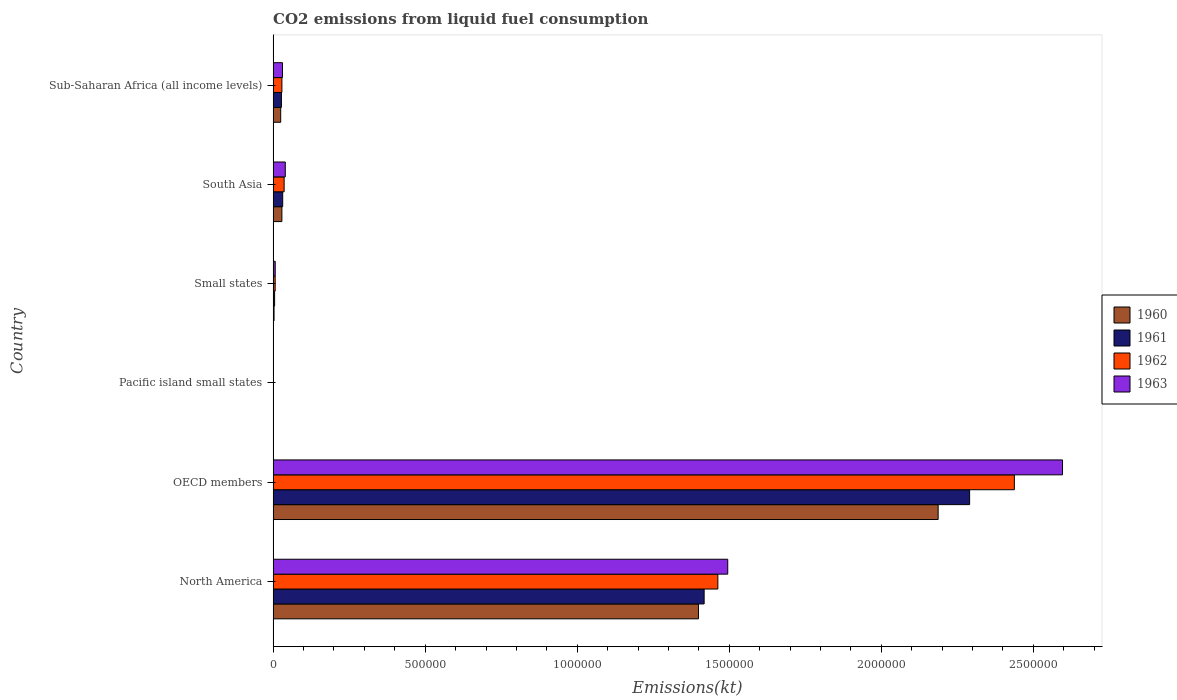How many groups of bars are there?
Offer a terse response. 6. Are the number of bars per tick equal to the number of legend labels?
Keep it short and to the point. Yes. How many bars are there on the 3rd tick from the top?
Provide a succinct answer. 4. How many bars are there on the 1st tick from the bottom?
Give a very brief answer. 4. What is the label of the 4th group of bars from the top?
Your answer should be compact. Pacific island small states. What is the amount of CO2 emitted in 1960 in OECD members?
Offer a terse response. 2.19e+06. Across all countries, what is the maximum amount of CO2 emitted in 1963?
Your response must be concise. 2.60e+06. Across all countries, what is the minimum amount of CO2 emitted in 1962?
Provide a succinct answer. 383.86. In which country was the amount of CO2 emitted in 1961 minimum?
Your answer should be compact. Pacific island small states. What is the total amount of CO2 emitted in 1963 in the graph?
Keep it short and to the point. 4.17e+06. What is the difference between the amount of CO2 emitted in 1960 in OECD members and that in Small states?
Give a very brief answer. 2.18e+06. What is the difference between the amount of CO2 emitted in 1963 in Sub-Saharan Africa (all income levels) and the amount of CO2 emitted in 1962 in Small states?
Keep it short and to the point. 2.41e+04. What is the average amount of CO2 emitted in 1961 per country?
Provide a short and direct response. 6.29e+05. What is the difference between the amount of CO2 emitted in 1962 and amount of CO2 emitted in 1963 in Small states?
Ensure brevity in your answer.  -173.55. What is the ratio of the amount of CO2 emitted in 1960 in North America to that in South Asia?
Offer a terse response. 48.52. Is the amount of CO2 emitted in 1963 in Pacific island small states less than that in Sub-Saharan Africa (all income levels)?
Your answer should be compact. Yes. Is the difference between the amount of CO2 emitted in 1962 in OECD members and Sub-Saharan Africa (all income levels) greater than the difference between the amount of CO2 emitted in 1963 in OECD members and Sub-Saharan Africa (all income levels)?
Offer a very short reply. No. What is the difference between the highest and the second highest amount of CO2 emitted in 1961?
Your answer should be very brief. 8.73e+05. What is the difference between the highest and the lowest amount of CO2 emitted in 1962?
Offer a very short reply. 2.44e+06. What does the 1st bar from the top in Pacific island small states represents?
Provide a short and direct response. 1963. What does the 4th bar from the bottom in Small states represents?
Offer a very short reply. 1963. What is the difference between two consecutive major ticks on the X-axis?
Ensure brevity in your answer.  5.00e+05. Are the values on the major ticks of X-axis written in scientific E-notation?
Keep it short and to the point. No. Does the graph contain any zero values?
Keep it short and to the point. No. Does the graph contain grids?
Offer a very short reply. No. Where does the legend appear in the graph?
Provide a short and direct response. Center right. How many legend labels are there?
Make the answer very short. 4. How are the legend labels stacked?
Keep it short and to the point. Vertical. What is the title of the graph?
Offer a terse response. CO2 emissions from liquid fuel consumption. Does "1977" appear as one of the legend labels in the graph?
Your response must be concise. No. What is the label or title of the X-axis?
Ensure brevity in your answer.  Emissions(kt). What is the label or title of the Y-axis?
Offer a very short reply. Country. What is the Emissions(kt) of 1960 in North America?
Your response must be concise. 1.40e+06. What is the Emissions(kt) in 1961 in North America?
Offer a terse response. 1.42e+06. What is the Emissions(kt) of 1962 in North America?
Your response must be concise. 1.46e+06. What is the Emissions(kt) in 1963 in North America?
Your answer should be compact. 1.49e+06. What is the Emissions(kt) in 1960 in OECD members?
Offer a very short reply. 2.19e+06. What is the Emissions(kt) in 1961 in OECD members?
Give a very brief answer. 2.29e+06. What is the Emissions(kt) in 1962 in OECD members?
Provide a succinct answer. 2.44e+06. What is the Emissions(kt) in 1963 in OECD members?
Your response must be concise. 2.60e+06. What is the Emissions(kt) of 1960 in Pacific island small states?
Your answer should be very brief. 281.37. What is the Emissions(kt) in 1961 in Pacific island small states?
Ensure brevity in your answer.  317.67. What is the Emissions(kt) in 1962 in Pacific island small states?
Ensure brevity in your answer.  383.86. What is the Emissions(kt) of 1963 in Pacific island small states?
Provide a short and direct response. 412.14. What is the Emissions(kt) of 1960 in Small states?
Provide a short and direct response. 3043.74. What is the Emissions(kt) in 1961 in Small states?
Provide a succinct answer. 4870.9. What is the Emissions(kt) in 1962 in Small states?
Provide a short and direct response. 6726.15. What is the Emissions(kt) of 1963 in Small states?
Give a very brief answer. 6899.7. What is the Emissions(kt) of 1960 in South Asia?
Give a very brief answer. 2.88e+04. What is the Emissions(kt) in 1961 in South Asia?
Keep it short and to the point. 3.15e+04. What is the Emissions(kt) of 1962 in South Asia?
Your answer should be very brief. 3.62e+04. What is the Emissions(kt) in 1963 in South Asia?
Ensure brevity in your answer.  4.00e+04. What is the Emissions(kt) of 1960 in Sub-Saharan Africa (all income levels)?
Keep it short and to the point. 2.49e+04. What is the Emissions(kt) in 1961 in Sub-Saharan Africa (all income levels)?
Your response must be concise. 2.73e+04. What is the Emissions(kt) of 1962 in Sub-Saharan Africa (all income levels)?
Your answer should be very brief. 2.89e+04. What is the Emissions(kt) in 1963 in Sub-Saharan Africa (all income levels)?
Your answer should be very brief. 3.08e+04. Across all countries, what is the maximum Emissions(kt) of 1960?
Offer a terse response. 2.19e+06. Across all countries, what is the maximum Emissions(kt) in 1961?
Your response must be concise. 2.29e+06. Across all countries, what is the maximum Emissions(kt) of 1962?
Provide a succinct answer. 2.44e+06. Across all countries, what is the maximum Emissions(kt) of 1963?
Ensure brevity in your answer.  2.60e+06. Across all countries, what is the minimum Emissions(kt) in 1960?
Keep it short and to the point. 281.37. Across all countries, what is the minimum Emissions(kt) of 1961?
Your response must be concise. 317.67. Across all countries, what is the minimum Emissions(kt) of 1962?
Provide a succinct answer. 383.86. Across all countries, what is the minimum Emissions(kt) of 1963?
Offer a very short reply. 412.14. What is the total Emissions(kt) of 1960 in the graph?
Your answer should be very brief. 3.64e+06. What is the total Emissions(kt) in 1961 in the graph?
Provide a short and direct response. 3.77e+06. What is the total Emissions(kt) of 1962 in the graph?
Make the answer very short. 3.97e+06. What is the total Emissions(kt) of 1963 in the graph?
Your response must be concise. 4.17e+06. What is the difference between the Emissions(kt) in 1960 in North America and that in OECD members?
Keep it short and to the point. -7.88e+05. What is the difference between the Emissions(kt) in 1961 in North America and that in OECD members?
Provide a short and direct response. -8.73e+05. What is the difference between the Emissions(kt) in 1962 in North America and that in OECD members?
Offer a very short reply. -9.75e+05. What is the difference between the Emissions(kt) of 1963 in North America and that in OECD members?
Offer a very short reply. -1.10e+06. What is the difference between the Emissions(kt) of 1960 in North America and that in Pacific island small states?
Make the answer very short. 1.40e+06. What is the difference between the Emissions(kt) of 1961 in North America and that in Pacific island small states?
Keep it short and to the point. 1.42e+06. What is the difference between the Emissions(kt) in 1962 in North America and that in Pacific island small states?
Provide a succinct answer. 1.46e+06. What is the difference between the Emissions(kt) of 1963 in North America and that in Pacific island small states?
Your answer should be compact. 1.49e+06. What is the difference between the Emissions(kt) of 1960 in North America and that in Small states?
Keep it short and to the point. 1.40e+06. What is the difference between the Emissions(kt) in 1961 in North America and that in Small states?
Give a very brief answer. 1.41e+06. What is the difference between the Emissions(kt) in 1962 in North America and that in Small states?
Your answer should be very brief. 1.46e+06. What is the difference between the Emissions(kt) in 1963 in North America and that in Small states?
Keep it short and to the point. 1.49e+06. What is the difference between the Emissions(kt) in 1960 in North America and that in South Asia?
Give a very brief answer. 1.37e+06. What is the difference between the Emissions(kt) in 1961 in North America and that in South Asia?
Your answer should be very brief. 1.39e+06. What is the difference between the Emissions(kt) in 1962 in North America and that in South Asia?
Keep it short and to the point. 1.43e+06. What is the difference between the Emissions(kt) of 1963 in North America and that in South Asia?
Give a very brief answer. 1.45e+06. What is the difference between the Emissions(kt) in 1960 in North America and that in Sub-Saharan Africa (all income levels)?
Your answer should be very brief. 1.37e+06. What is the difference between the Emissions(kt) of 1961 in North America and that in Sub-Saharan Africa (all income levels)?
Provide a succinct answer. 1.39e+06. What is the difference between the Emissions(kt) in 1962 in North America and that in Sub-Saharan Africa (all income levels)?
Provide a succinct answer. 1.43e+06. What is the difference between the Emissions(kt) in 1963 in North America and that in Sub-Saharan Africa (all income levels)?
Offer a terse response. 1.46e+06. What is the difference between the Emissions(kt) of 1960 in OECD members and that in Pacific island small states?
Offer a very short reply. 2.19e+06. What is the difference between the Emissions(kt) of 1961 in OECD members and that in Pacific island small states?
Ensure brevity in your answer.  2.29e+06. What is the difference between the Emissions(kt) of 1962 in OECD members and that in Pacific island small states?
Give a very brief answer. 2.44e+06. What is the difference between the Emissions(kt) of 1963 in OECD members and that in Pacific island small states?
Offer a terse response. 2.60e+06. What is the difference between the Emissions(kt) of 1960 in OECD members and that in Small states?
Make the answer very short. 2.18e+06. What is the difference between the Emissions(kt) of 1961 in OECD members and that in Small states?
Offer a very short reply. 2.29e+06. What is the difference between the Emissions(kt) of 1962 in OECD members and that in Small states?
Provide a short and direct response. 2.43e+06. What is the difference between the Emissions(kt) in 1963 in OECD members and that in Small states?
Give a very brief answer. 2.59e+06. What is the difference between the Emissions(kt) of 1960 in OECD members and that in South Asia?
Your answer should be very brief. 2.16e+06. What is the difference between the Emissions(kt) in 1961 in OECD members and that in South Asia?
Keep it short and to the point. 2.26e+06. What is the difference between the Emissions(kt) in 1962 in OECD members and that in South Asia?
Give a very brief answer. 2.40e+06. What is the difference between the Emissions(kt) of 1963 in OECD members and that in South Asia?
Your answer should be very brief. 2.56e+06. What is the difference between the Emissions(kt) of 1960 in OECD members and that in Sub-Saharan Africa (all income levels)?
Provide a succinct answer. 2.16e+06. What is the difference between the Emissions(kt) in 1961 in OECD members and that in Sub-Saharan Africa (all income levels)?
Provide a short and direct response. 2.26e+06. What is the difference between the Emissions(kt) of 1962 in OECD members and that in Sub-Saharan Africa (all income levels)?
Your answer should be compact. 2.41e+06. What is the difference between the Emissions(kt) of 1963 in OECD members and that in Sub-Saharan Africa (all income levels)?
Offer a very short reply. 2.56e+06. What is the difference between the Emissions(kt) of 1960 in Pacific island small states and that in Small states?
Provide a succinct answer. -2762.37. What is the difference between the Emissions(kt) in 1961 in Pacific island small states and that in Small states?
Your response must be concise. -4553.22. What is the difference between the Emissions(kt) of 1962 in Pacific island small states and that in Small states?
Make the answer very short. -6342.29. What is the difference between the Emissions(kt) in 1963 in Pacific island small states and that in Small states?
Offer a very short reply. -6487.56. What is the difference between the Emissions(kt) of 1960 in Pacific island small states and that in South Asia?
Your answer should be very brief. -2.85e+04. What is the difference between the Emissions(kt) of 1961 in Pacific island small states and that in South Asia?
Give a very brief answer. -3.12e+04. What is the difference between the Emissions(kt) in 1962 in Pacific island small states and that in South Asia?
Provide a short and direct response. -3.58e+04. What is the difference between the Emissions(kt) in 1963 in Pacific island small states and that in South Asia?
Provide a short and direct response. -3.96e+04. What is the difference between the Emissions(kt) in 1960 in Pacific island small states and that in Sub-Saharan Africa (all income levels)?
Offer a terse response. -2.46e+04. What is the difference between the Emissions(kt) of 1961 in Pacific island small states and that in Sub-Saharan Africa (all income levels)?
Ensure brevity in your answer.  -2.70e+04. What is the difference between the Emissions(kt) in 1962 in Pacific island small states and that in Sub-Saharan Africa (all income levels)?
Offer a terse response. -2.85e+04. What is the difference between the Emissions(kt) of 1963 in Pacific island small states and that in Sub-Saharan Africa (all income levels)?
Offer a very short reply. -3.04e+04. What is the difference between the Emissions(kt) in 1960 in Small states and that in South Asia?
Keep it short and to the point. -2.58e+04. What is the difference between the Emissions(kt) in 1961 in Small states and that in South Asia?
Your answer should be compact. -2.66e+04. What is the difference between the Emissions(kt) in 1962 in Small states and that in South Asia?
Your answer should be very brief. -2.95e+04. What is the difference between the Emissions(kt) in 1963 in Small states and that in South Asia?
Keep it short and to the point. -3.31e+04. What is the difference between the Emissions(kt) in 1960 in Small states and that in Sub-Saharan Africa (all income levels)?
Your response must be concise. -2.19e+04. What is the difference between the Emissions(kt) in 1961 in Small states and that in Sub-Saharan Africa (all income levels)?
Provide a succinct answer. -2.25e+04. What is the difference between the Emissions(kt) in 1962 in Small states and that in Sub-Saharan Africa (all income levels)?
Make the answer very short. -2.22e+04. What is the difference between the Emissions(kt) of 1963 in Small states and that in Sub-Saharan Africa (all income levels)?
Your answer should be compact. -2.39e+04. What is the difference between the Emissions(kt) of 1960 in South Asia and that in Sub-Saharan Africa (all income levels)?
Provide a succinct answer. 3916.59. What is the difference between the Emissions(kt) in 1961 in South Asia and that in Sub-Saharan Africa (all income levels)?
Provide a short and direct response. 4173.93. What is the difference between the Emissions(kt) of 1962 in South Asia and that in Sub-Saharan Africa (all income levels)?
Provide a succinct answer. 7305.47. What is the difference between the Emissions(kt) in 1963 in South Asia and that in Sub-Saharan Africa (all income levels)?
Make the answer very short. 9178.66. What is the difference between the Emissions(kt) in 1960 in North America and the Emissions(kt) in 1961 in OECD members?
Your answer should be compact. -8.92e+05. What is the difference between the Emissions(kt) in 1960 in North America and the Emissions(kt) in 1962 in OECD members?
Your response must be concise. -1.04e+06. What is the difference between the Emissions(kt) in 1960 in North America and the Emissions(kt) in 1963 in OECD members?
Your response must be concise. -1.20e+06. What is the difference between the Emissions(kt) in 1961 in North America and the Emissions(kt) in 1962 in OECD members?
Your answer should be compact. -1.02e+06. What is the difference between the Emissions(kt) of 1961 in North America and the Emissions(kt) of 1963 in OECD members?
Offer a terse response. -1.18e+06. What is the difference between the Emissions(kt) in 1962 in North America and the Emissions(kt) in 1963 in OECD members?
Ensure brevity in your answer.  -1.13e+06. What is the difference between the Emissions(kt) in 1960 in North America and the Emissions(kt) in 1961 in Pacific island small states?
Make the answer very short. 1.40e+06. What is the difference between the Emissions(kt) in 1960 in North America and the Emissions(kt) in 1962 in Pacific island small states?
Offer a terse response. 1.40e+06. What is the difference between the Emissions(kt) in 1960 in North America and the Emissions(kt) in 1963 in Pacific island small states?
Make the answer very short. 1.40e+06. What is the difference between the Emissions(kt) of 1961 in North America and the Emissions(kt) of 1962 in Pacific island small states?
Your answer should be compact. 1.42e+06. What is the difference between the Emissions(kt) of 1961 in North America and the Emissions(kt) of 1963 in Pacific island small states?
Give a very brief answer. 1.42e+06. What is the difference between the Emissions(kt) in 1962 in North America and the Emissions(kt) in 1963 in Pacific island small states?
Give a very brief answer. 1.46e+06. What is the difference between the Emissions(kt) in 1960 in North America and the Emissions(kt) in 1961 in Small states?
Make the answer very short. 1.39e+06. What is the difference between the Emissions(kt) in 1960 in North America and the Emissions(kt) in 1962 in Small states?
Your answer should be compact. 1.39e+06. What is the difference between the Emissions(kt) in 1960 in North America and the Emissions(kt) in 1963 in Small states?
Ensure brevity in your answer.  1.39e+06. What is the difference between the Emissions(kt) in 1961 in North America and the Emissions(kt) in 1962 in Small states?
Make the answer very short. 1.41e+06. What is the difference between the Emissions(kt) of 1961 in North America and the Emissions(kt) of 1963 in Small states?
Your response must be concise. 1.41e+06. What is the difference between the Emissions(kt) of 1962 in North America and the Emissions(kt) of 1963 in Small states?
Your response must be concise. 1.46e+06. What is the difference between the Emissions(kt) in 1960 in North America and the Emissions(kt) in 1961 in South Asia?
Provide a succinct answer. 1.37e+06. What is the difference between the Emissions(kt) of 1960 in North America and the Emissions(kt) of 1962 in South Asia?
Your answer should be very brief. 1.36e+06. What is the difference between the Emissions(kt) of 1960 in North America and the Emissions(kt) of 1963 in South Asia?
Keep it short and to the point. 1.36e+06. What is the difference between the Emissions(kt) in 1961 in North America and the Emissions(kt) in 1962 in South Asia?
Make the answer very short. 1.38e+06. What is the difference between the Emissions(kt) of 1961 in North America and the Emissions(kt) of 1963 in South Asia?
Offer a very short reply. 1.38e+06. What is the difference between the Emissions(kt) of 1962 in North America and the Emissions(kt) of 1963 in South Asia?
Keep it short and to the point. 1.42e+06. What is the difference between the Emissions(kt) of 1960 in North America and the Emissions(kt) of 1961 in Sub-Saharan Africa (all income levels)?
Make the answer very short. 1.37e+06. What is the difference between the Emissions(kt) of 1960 in North America and the Emissions(kt) of 1962 in Sub-Saharan Africa (all income levels)?
Provide a succinct answer. 1.37e+06. What is the difference between the Emissions(kt) of 1960 in North America and the Emissions(kt) of 1963 in Sub-Saharan Africa (all income levels)?
Keep it short and to the point. 1.37e+06. What is the difference between the Emissions(kt) of 1961 in North America and the Emissions(kt) of 1962 in Sub-Saharan Africa (all income levels)?
Your answer should be very brief. 1.39e+06. What is the difference between the Emissions(kt) of 1961 in North America and the Emissions(kt) of 1963 in Sub-Saharan Africa (all income levels)?
Provide a succinct answer. 1.39e+06. What is the difference between the Emissions(kt) of 1962 in North America and the Emissions(kt) of 1963 in Sub-Saharan Africa (all income levels)?
Your answer should be compact. 1.43e+06. What is the difference between the Emissions(kt) of 1960 in OECD members and the Emissions(kt) of 1961 in Pacific island small states?
Ensure brevity in your answer.  2.19e+06. What is the difference between the Emissions(kt) of 1960 in OECD members and the Emissions(kt) of 1962 in Pacific island small states?
Provide a succinct answer. 2.19e+06. What is the difference between the Emissions(kt) of 1960 in OECD members and the Emissions(kt) of 1963 in Pacific island small states?
Your answer should be very brief. 2.19e+06. What is the difference between the Emissions(kt) of 1961 in OECD members and the Emissions(kt) of 1962 in Pacific island small states?
Your answer should be compact. 2.29e+06. What is the difference between the Emissions(kt) in 1961 in OECD members and the Emissions(kt) in 1963 in Pacific island small states?
Your answer should be compact. 2.29e+06. What is the difference between the Emissions(kt) in 1962 in OECD members and the Emissions(kt) in 1963 in Pacific island small states?
Your answer should be compact. 2.44e+06. What is the difference between the Emissions(kt) in 1960 in OECD members and the Emissions(kt) in 1961 in Small states?
Ensure brevity in your answer.  2.18e+06. What is the difference between the Emissions(kt) of 1960 in OECD members and the Emissions(kt) of 1962 in Small states?
Offer a very short reply. 2.18e+06. What is the difference between the Emissions(kt) of 1960 in OECD members and the Emissions(kt) of 1963 in Small states?
Your answer should be very brief. 2.18e+06. What is the difference between the Emissions(kt) of 1961 in OECD members and the Emissions(kt) of 1962 in Small states?
Your answer should be compact. 2.28e+06. What is the difference between the Emissions(kt) of 1961 in OECD members and the Emissions(kt) of 1963 in Small states?
Ensure brevity in your answer.  2.28e+06. What is the difference between the Emissions(kt) of 1962 in OECD members and the Emissions(kt) of 1963 in Small states?
Your answer should be very brief. 2.43e+06. What is the difference between the Emissions(kt) in 1960 in OECD members and the Emissions(kt) in 1961 in South Asia?
Provide a short and direct response. 2.16e+06. What is the difference between the Emissions(kt) in 1960 in OECD members and the Emissions(kt) in 1962 in South Asia?
Your answer should be very brief. 2.15e+06. What is the difference between the Emissions(kt) in 1960 in OECD members and the Emissions(kt) in 1963 in South Asia?
Your response must be concise. 2.15e+06. What is the difference between the Emissions(kt) of 1961 in OECD members and the Emissions(kt) of 1962 in South Asia?
Give a very brief answer. 2.25e+06. What is the difference between the Emissions(kt) in 1961 in OECD members and the Emissions(kt) in 1963 in South Asia?
Your answer should be very brief. 2.25e+06. What is the difference between the Emissions(kt) in 1962 in OECD members and the Emissions(kt) in 1963 in South Asia?
Make the answer very short. 2.40e+06. What is the difference between the Emissions(kt) in 1960 in OECD members and the Emissions(kt) in 1961 in Sub-Saharan Africa (all income levels)?
Your answer should be very brief. 2.16e+06. What is the difference between the Emissions(kt) in 1960 in OECD members and the Emissions(kt) in 1962 in Sub-Saharan Africa (all income levels)?
Offer a terse response. 2.16e+06. What is the difference between the Emissions(kt) of 1960 in OECD members and the Emissions(kt) of 1963 in Sub-Saharan Africa (all income levels)?
Provide a short and direct response. 2.16e+06. What is the difference between the Emissions(kt) in 1961 in OECD members and the Emissions(kt) in 1962 in Sub-Saharan Africa (all income levels)?
Your response must be concise. 2.26e+06. What is the difference between the Emissions(kt) in 1961 in OECD members and the Emissions(kt) in 1963 in Sub-Saharan Africa (all income levels)?
Your answer should be very brief. 2.26e+06. What is the difference between the Emissions(kt) in 1962 in OECD members and the Emissions(kt) in 1963 in Sub-Saharan Africa (all income levels)?
Your answer should be compact. 2.41e+06. What is the difference between the Emissions(kt) of 1960 in Pacific island small states and the Emissions(kt) of 1961 in Small states?
Provide a succinct answer. -4589.53. What is the difference between the Emissions(kt) of 1960 in Pacific island small states and the Emissions(kt) of 1962 in Small states?
Make the answer very short. -6444.78. What is the difference between the Emissions(kt) in 1960 in Pacific island small states and the Emissions(kt) in 1963 in Small states?
Your response must be concise. -6618.33. What is the difference between the Emissions(kt) of 1961 in Pacific island small states and the Emissions(kt) of 1962 in Small states?
Ensure brevity in your answer.  -6408.48. What is the difference between the Emissions(kt) of 1961 in Pacific island small states and the Emissions(kt) of 1963 in Small states?
Your answer should be very brief. -6582.02. What is the difference between the Emissions(kt) of 1962 in Pacific island small states and the Emissions(kt) of 1963 in Small states?
Provide a succinct answer. -6515.84. What is the difference between the Emissions(kt) in 1960 in Pacific island small states and the Emissions(kt) in 1961 in South Asia?
Provide a short and direct response. -3.12e+04. What is the difference between the Emissions(kt) in 1960 in Pacific island small states and the Emissions(kt) in 1962 in South Asia?
Offer a terse response. -3.59e+04. What is the difference between the Emissions(kt) in 1960 in Pacific island small states and the Emissions(kt) in 1963 in South Asia?
Your response must be concise. -3.97e+04. What is the difference between the Emissions(kt) of 1961 in Pacific island small states and the Emissions(kt) of 1962 in South Asia?
Provide a succinct answer. -3.59e+04. What is the difference between the Emissions(kt) of 1961 in Pacific island small states and the Emissions(kt) of 1963 in South Asia?
Keep it short and to the point. -3.97e+04. What is the difference between the Emissions(kt) in 1962 in Pacific island small states and the Emissions(kt) in 1963 in South Asia?
Provide a short and direct response. -3.96e+04. What is the difference between the Emissions(kt) in 1960 in Pacific island small states and the Emissions(kt) in 1961 in Sub-Saharan Africa (all income levels)?
Make the answer very short. -2.71e+04. What is the difference between the Emissions(kt) of 1960 in Pacific island small states and the Emissions(kt) of 1962 in Sub-Saharan Africa (all income levels)?
Your response must be concise. -2.86e+04. What is the difference between the Emissions(kt) of 1960 in Pacific island small states and the Emissions(kt) of 1963 in Sub-Saharan Africa (all income levels)?
Make the answer very short. -3.05e+04. What is the difference between the Emissions(kt) in 1961 in Pacific island small states and the Emissions(kt) in 1962 in Sub-Saharan Africa (all income levels)?
Offer a terse response. -2.86e+04. What is the difference between the Emissions(kt) in 1961 in Pacific island small states and the Emissions(kt) in 1963 in Sub-Saharan Africa (all income levels)?
Make the answer very short. -3.05e+04. What is the difference between the Emissions(kt) in 1962 in Pacific island small states and the Emissions(kt) in 1963 in Sub-Saharan Africa (all income levels)?
Offer a very short reply. -3.04e+04. What is the difference between the Emissions(kt) of 1960 in Small states and the Emissions(kt) of 1961 in South Asia?
Your answer should be compact. -2.85e+04. What is the difference between the Emissions(kt) of 1960 in Small states and the Emissions(kt) of 1962 in South Asia?
Make the answer very short. -3.32e+04. What is the difference between the Emissions(kt) in 1960 in Small states and the Emissions(kt) in 1963 in South Asia?
Keep it short and to the point. -3.69e+04. What is the difference between the Emissions(kt) of 1961 in Small states and the Emissions(kt) of 1962 in South Asia?
Provide a short and direct response. -3.13e+04. What is the difference between the Emissions(kt) of 1961 in Small states and the Emissions(kt) of 1963 in South Asia?
Give a very brief answer. -3.51e+04. What is the difference between the Emissions(kt) of 1962 in Small states and the Emissions(kt) of 1963 in South Asia?
Keep it short and to the point. -3.33e+04. What is the difference between the Emissions(kt) of 1960 in Small states and the Emissions(kt) of 1961 in Sub-Saharan Africa (all income levels)?
Your response must be concise. -2.43e+04. What is the difference between the Emissions(kt) of 1960 in Small states and the Emissions(kt) of 1962 in Sub-Saharan Africa (all income levels)?
Provide a succinct answer. -2.58e+04. What is the difference between the Emissions(kt) of 1960 in Small states and the Emissions(kt) of 1963 in Sub-Saharan Africa (all income levels)?
Provide a succinct answer. -2.78e+04. What is the difference between the Emissions(kt) of 1961 in Small states and the Emissions(kt) of 1962 in Sub-Saharan Africa (all income levels)?
Make the answer very short. -2.40e+04. What is the difference between the Emissions(kt) in 1961 in Small states and the Emissions(kt) in 1963 in Sub-Saharan Africa (all income levels)?
Provide a succinct answer. -2.59e+04. What is the difference between the Emissions(kt) of 1962 in Small states and the Emissions(kt) of 1963 in Sub-Saharan Africa (all income levels)?
Provide a succinct answer. -2.41e+04. What is the difference between the Emissions(kt) in 1960 in South Asia and the Emissions(kt) in 1961 in Sub-Saharan Africa (all income levels)?
Offer a terse response. 1497.94. What is the difference between the Emissions(kt) of 1960 in South Asia and the Emissions(kt) of 1962 in Sub-Saharan Africa (all income levels)?
Offer a very short reply. -62.97. What is the difference between the Emissions(kt) in 1960 in South Asia and the Emissions(kt) in 1963 in Sub-Saharan Africa (all income levels)?
Your answer should be compact. -1980.13. What is the difference between the Emissions(kt) in 1961 in South Asia and the Emissions(kt) in 1962 in Sub-Saharan Africa (all income levels)?
Provide a short and direct response. 2613.02. What is the difference between the Emissions(kt) of 1961 in South Asia and the Emissions(kt) of 1963 in Sub-Saharan Africa (all income levels)?
Your answer should be compact. 695.86. What is the difference between the Emissions(kt) of 1962 in South Asia and the Emissions(kt) of 1963 in Sub-Saharan Africa (all income levels)?
Offer a very short reply. 5388.31. What is the average Emissions(kt) of 1960 per country?
Ensure brevity in your answer.  6.07e+05. What is the average Emissions(kt) of 1961 per country?
Offer a very short reply. 6.29e+05. What is the average Emissions(kt) in 1962 per country?
Keep it short and to the point. 6.62e+05. What is the average Emissions(kt) in 1963 per country?
Make the answer very short. 6.95e+05. What is the difference between the Emissions(kt) of 1960 and Emissions(kt) of 1961 in North America?
Keep it short and to the point. -1.86e+04. What is the difference between the Emissions(kt) of 1960 and Emissions(kt) of 1962 in North America?
Keep it short and to the point. -6.37e+04. What is the difference between the Emissions(kt) of 1960 and Emissions(kt) of 1963 in North America?
Keep it short and to the point. -9.62e+04. What is the difference between the Emissions(kt) of 1961 and Emissions(kt) of 1962 in North America?
Give a very brief answer. -4.51e+04. What is the difference between the Emissions(kt) in 1961 and Emissions(kt) in 1963 in North America?
Provide a short and direct response. -7.76e+04. What is the difference between the Emissions(kt) of 1962 and Emissions(kt) of 1963 in North America?
Your answer should be very brief. -3.25e+04. What is the difference between the Emissions(kt) in 1960 and Emissions(kt) in 1961 in OECD members?
Your answer should be compact. -1.04e+05. What is the difference between the Emissions(kt) in 1960 and Emissions(kt) in 1962 in OECD members?
Your answer should be compact. -2.51e+05. What is the difference between the Emissions(kt) of 1960 and Emissions(kt) of 1963 in OECD members?
Provide a short and direct response. -4.09e+05. What is the difference between the Emissions(kt) of 1961 and Emissions(kt) of 1962 in OECD members?
Your answer should be compact. -1.47e+05. What is the difference between the Emissions(kt) of 1961 and Emissions(kt) of 1963 in OECD members?
Your response must be concise. -3.05e+05. What is the difference between the Emissions(kt) of 1962 and Emissions(kt) of 1963 in OECD members?
Provide a short and direct response. -1.58e+05. What is the difference between the Emissions(kt) in 1960 and Emissions(kt) in 1961 in Pacific island small states?
Offer a very short reply. -36.31. What is the difference between the Emissions(kt) of 1960 and Emissions(kt) of 1962 in Pacific island small states?
Your response must be concise. -102.49. What is the difference between the Emissions(kt) in 1960 and Emissions(kt) in 1963 in Pacific island small states?
Provide a succinct answer. -130.77. What is the difference between the Emissions(kt) in 1961 and Emissions(kt) in 1962 in Pacific island small states?
Provide a short and direct response. -66.18. What is the difference between the Emissions(kt) in 1961 and Emissions(kt) in 1963 in Pacific island small states?
Offer a very short reply. -94.47. What is the difference between the Emissions(kt) of 1962 and Emissions(kt) of 1963 in Pacific island small states?
Offer a very short reply. -28.28. What is the difference between the Emissions(kt) in 1960 and Emissions(kt) in 1961 in Small states?
Your response must be concise. -1827.16. What is the difference between the Emissions(kt) of 1960 and Emissions(kt) of 1962 in Small states?
Offer a very short reply. -3682.41. What is the difference between the Emissions(kt) of 1960 and Emissions(kt) of 1963 in Small states?
Your answer should be compact. -3855.96. What is the difference between the Emissions(kt) in 1961 and Emissions(kt) in 1962 in Small states?
Keep it short and to the point. -1855.25. What is the difference between the Emissions(kt) in 1961 and Emissions(kt) in 1963 in Small states?
Offer a terse response. -2028.8. What is the difference between the Emissions(kt) in 1962 and Emissions(kt) in 1963 in Small states?
Your answer should be very brief. -173.55. What is the difference between the Emissions(kt) in 1960 and Emissions(kt) in 1961 in South Asia?
Provide a short and direct response. -2675.99. What is the difference between the Emissions(kt) of 1960 and Emissions(kt) of 1962 in South Asia?
Make the answer very short. -7368.44. What is the difference between the Emissions(kt) in 1960 and Emissions(kt) in 1963 in South Asia?
Offer a very short reply. -1.12e+04. What is the difference between the Emissions(kt) of 1961 and Emissions(kt) of 1962 in South Asia?
Your response must be concise. -4692.46. What is the difference between the Emissions(kt) in 1961 and Emissions(kt) in 1963 in South Asia?
Provide a succinct answer. -8482.81. What is the difference between the Emissions(kt) of 1962 and Emissions(kt) of 1963 in South Asia?
Your response must be concise. -3790.35. What is the difference between the Emissions(kt) of 1960 and Emissions(kt) of 1961 in Sub-Saharan Africa (all income levels)?
Make the answer very short. -2418.65. What is the difference between the Emissions(kt) of 1960 and Emissions(kt) of 1962 in Sub-Saharan Africa (all income levels)?
Keep it short and to the point. -3979.56. What is the difference between the Emissions(kt) in 1960 and Emissions(kt) in 1963 in Sub-Saharan Africa (all income levels)?
Offer a very short reply. -5896.72. What is the difference between the Emissions(kt) in 1961 and Emissions(kt) in 1962 in Sub-Saharan Africa (all income levels)?
Provide a short and direct response. -1560.92. What is the difference between the Emissions(kt) of 1961 and Emissions(kt) of 1963 in Sub-Saharan Africa (all income levels)?
Keep it short and to the point. -3478.07. What is the difference between the Emissions(kt) of 1962 and Emissions(kt) of 1963 in Sub-Saharan Africa (all income levels)?
Make the answer very short. -1917.16. What is the ratio of the Emissions(kt) of 1960 in North America to that in OECD members?
Your answer should be compact. 0.64. What is the ratio of the Emissions(kt) of 1961 in North America to that in OECD members?
Give a very brief answer. 0.62. What is the ratio of the Emissions(kt) of 1962 in North America to that in OECD members?
Offer a very short reply. 0.6. What is the ratio of the Emissions(kt) in 1963 in North America to that in OECD members?
Ensure brevity in your answer.  0.58. What is the ratio of the Emissions(kt) of 1960 in North America to that in Pacific island small states?
Your answer should be compact. 4970.96. What is the ratio of the Emissions(kt) in 1961 in North America to that in Pacific island small states?
Your response must be concise. 4461.53. What is the ratio of the Emissions(kt) in 1962 in North America to that in Pacific island small states?
Offer a very short reply. 3809.72. What is the ratio of the Emissions(kt) of 1963 in North America to that in Pacific island small states?
Your answer should be compact. 3627.16. What is the ratio of the Emissions(kt) of 1960 in North America to that in Small states?
Provide a succinct answer. 459.53. What is the ratio of the Emissions(kt) of 1961 in North America to that in Small states?
Keep it short and to the point. 290.98. What is the ratio of the Emissions(kt) of 1962 in North America to that in Small states?
Offer a terse response. 217.42. What is the ratio of the Emissions(kt) in 1963 in North America to that in Small states?
Your response must be concise. 216.66. What is the ratio of the Emissions(kt) of 1960 in North America to that in South Asia?
Make the answer very short. 48.52. What is the ratio of the Emissions(kt) in 1961 in North America to that in South Asia?
Your response must be concise. 44.99. What is the ratio of the Emissions(kt) of 1962 in North America to that in South Asia?
Ensure brevity in your answer.  40.4. What is the ratio of the Emissions(kt) in 1963 in North America to that in South Asia?
Give a very brief answer. 37.38. What is the ratio of the Emissions(kt) of 1960 in North America to that in Sub-Saharan Africa (all income levels)?
Your answer should be compact. 56.14. What is the ratio of the Emissions(kt) of 1961 in North America to that in Sub-Saharan Africa (all income levels)?
Offer a terse response. 51.86. What is the ratio of the Emissions(kt) of 1962 in North America to that in Sub-Saharan Africa (all income levels)?
Ensure brevity in your answer.  50.62. What is the ratio of the Emissions(kt) of 1963 in North America to that in Sub-Saharan Africa (all income levels)?
Make the answer very short. 48.52. What is the ratio of the Emissions(kt) of 1960 in OECD members to that in Pacific island small states?
Your answer should be compact. 7771.89. What is the ratio of the Emissions(kt) of 1961 in OECD members to that in Pacific island small states?
Provide a succinct answer. 7209.53. What is the ratio of the Emissions(kt) of 1962 in OECD members to that in Pacific island small states?
Make the answer very short. 6349.78. What is the ratio of the Emissions(kt) in 1963 in OECD members to that in Pacific island small states?
Your response must be concise. 6298.21. What is the ratio of the Emissions(kt) of 1960 in OECD members to that in Small states?
Your answer should be compact. 718.45. What is the ratio of the Emissions(kt) in 1961 in OECD members to that in Small states?
Offer a terse response. 470.2. What is the ratio of the Emissions(kt) in 1962 in OECD members to that in Small states?
Offer a very short reply. 362.38. What is the ratio of the Emissions(kt) of 1963 in OECD members to that in Small states?
Give a very brief answer. 376.21. What is the ratio of the Emissions(kt) in 1960 in OECD members to that in South Asia?
Your answer should be very brief. 75.85. What is the ratio of the Emissions(kt) of 1961 in OECD members to that in South Asia?
Offer a terse response. 72.69. What is the ratio of the Emissions(kt) of 1962 in OECD members to that in South Asia?
Your answer should be very brief. 67.34. What is the ratio of the Emissions(kt) in 1963 in OECD members to that in South Asia?
Give a very brief answer. 64.91. What is the ratio of the Emissions(kt) of 1960 in OECD members to that in Sub-Saharan Africa (all income levels)?
Your response must be concise. 87.78. What is the ratio of the Emissions(kt) in 1961 in OECD members to that in Sub-Saharan Africa (all income levels)?
Keep it short and to the point. 83.8. What is the ratio of the Emissions(kt) in 1962 in OECD members to that in Sub-Saharan Africa (all income levels)?
Your response must be concise. 84.36. What is the ratio of the Emissions(kt) of 1963 in OECD members to that in Sub-Saharan Africa (all income levels)?
Keep it short and to the point. 84.25. What is the ratio of the Emissions(kt) in 1960 in Pacific island small states to that in Small states?
Offer a very short reply. 0.09. What is the ratio of the Emissions(kt) of 1961 in Pacific island small states to that in Small states?
Ensure brevity in your answer.  0.07. What is the ratio of the Emissions(kt) of 1962 in Pacific island small states to that in Small states?
Your response must be concise. 0.06. What is the ratio of the Emissions(kt) of 1963 in Pacific island small states to that in Small states?
Your response must be concise. 0.06. What is the ratio of the Emissions(kt) of 1960 in Pacific island small states to that in South Asia?
Provide a succinct answer. 0.01. What is the ratio of the Emissions(kt) in 1961 in Pacific island small states to that in South Asia?
Your response must be concise. 0.01. What is the ratio of the Emissions(kt) in 1962 in Pacific island small states to that in South Asia?
Your answer should be compact. 0.01. What is the ratio of the Emissions(kt) of 1963 in Pacific island small states to that in South Asia?
Your response must be concise. 0.01. What is the ratio of the Emissions(kt) in 1960 in Pacific island small states to that in Sub-Saharan Africa (all income levels)?
Make the answer very short. 0.01. What is the ratio of the Emissions(kt) of 1961 in Pacific island small states to that in Sub-Saharan Africa (all income levels)?
Your response must be concise. 0.01. What is the ratio of the Emissions(kt) in 1962 in Pacific island small states to that in Sub-Saharan Africa (all income levels)?
Ensure brevity in your answer.  0.01. What is the ratio of the Emissions(kt) in 1963 in Pacific island small states to that in Sub-Saharan Africa (all income levels)?
Ensure brevity in your answer.  0.01. What is the ratio of the Emissions(kt) in 1960 in Small states to that in South Asia?
Your answer should be compact. 0.11. What is the ratio of the Emissions(kt) of 1961 in Small states to that in South Asia?
Ensure brevity in your answer.  0.15. What is the ratio of the Emissions(kt) of 1962 in Small states to that in South Asia?
Your answer should be very brief. 0.19. What is the ratio of the Emissions(kt) in 1963 in Small states to that in South Asia?
Your answer should be compact. 0.17. What is the ratio of the Emissions(kt) in 1960 in Small states to that in Sub-Saharan Africa (all income levels)?
Make the answer very short. 0.12. What is the ratio of the Emissions(kt) in 1961 in Small states to that in Sub-Saharan Africa (all income levels)?
Offer a very short reply. 0.18. What is the ratio of the Emissions(kt) in 1962 in Small states to that in Sub-Saharan Africa (all income levels)?
Offer a very short reply. 0.23. What is the ratio of the Emissions(kt) in 1963 in Small states to that in Sub-Saharan Africa (all income levels)?
Your response must be concise. 0.22. What is the ratio of the Emissions(kt) of 1960 in South Asia to that in Sub-Saharan Africa (all income levels)?
Your response must be concise. 1.16. What is the ratio of the Emissions(kt) of 1961 in South Asia to that in Sub-Saharan Africa (all income levels)?
Provide a succinct answer. 1.15. What is the ratio of the Emissions(kt) in 1962 in South Asia to that in Sub-Saharan Africa (all income levels)?
Your answer should be compact. 1.25. What is the ratio of the Emissions(kt) of 1963 in South Asia to that in Sub-Saharan Africa (all income levels)?
Your answer should be very brief. 1.3. What is the difference between the highest and the second highest Emissions(kt) in 1960?
Ensure brevity in your answer.  7.88e+05. What is the difference between the highest and the second highest Emissions(kt) in 1961?
Keep it short and to the point. 8.73e+05. What is the difference between the highest and the second highest Emissions(kt) in 1962?
Provide a succinct answer. 9.75e+05. What is the difference between the highest and the second highest Emissions(kt) of 1963?
Offer a very short reply. 1.10e+06. What is the difference between the highest and the lowest Emissions(kt) of 1960?
Offer a terse response. 2.19e+06. What is the difference between the highest and the lowest Emissions(kt) in 1961?
Keep it short and to the point. 2.29e+06. What is the difference between the highest and the lowest Emissions(kt) in 1962?
Your answer should be compact. 2.44e+06. What is the difference between the highest and the lowest Emissions(kt) of 1963?
Make the answer very short. 2.60e+06. 